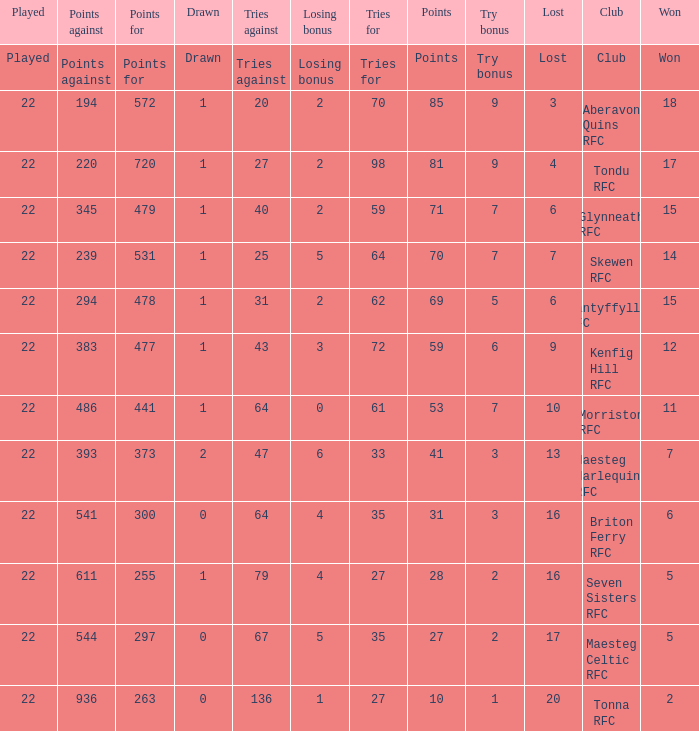How many tries against got the club with 62 tries for? 31.0. 